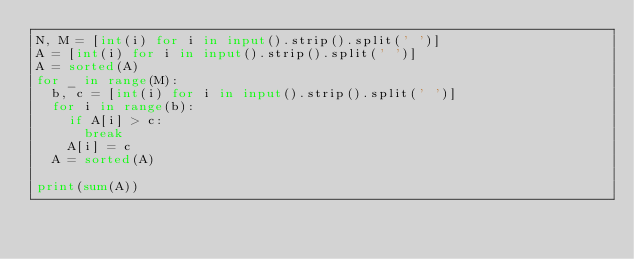Convert code to text. <code><loc_0><loc_0><loc_500><loc_500><_Python_>N, M = [int(i) for i in input().strip().split(' ')]
A = [int(i) for i in input().strip().split(' ')]
A = sorted(A)
for _ in range(M):
  b, c = [int(i) for i in input().strip().split(' ')]
  for i in range(b):
    if A[i] > c:
      break
    A[i] = c
  A = sorted(A)

print(sum(A))</code> 